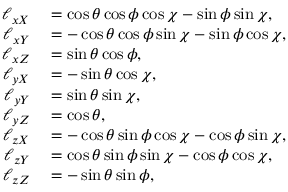Convert formula to latex. <formula><loc_0><loc_0><loc_500><loc_500>\begin{array} { r l } { \ell _ { x X } } & = \cos \theta \cos \phi \cos \chi - \sin \phi \sin \chi , } \\ { \ell _ { x Y } } & = - \cos \theta \cos \phi \sin \chi - \sin \phi \cos \chi , } \\ { \ell _ { x Z } } & = \sin \theta \cos \phi , } \\ { \ell _ { y X } } & = - \sin \theta \cos \chi , } \\ { \ell _ { y Y } } & = \sin \theta \sin \chi , } \\ { \ell _ { y Z } } & = \cos \theta , } \\ { \ell _ { z X } } & = - \cos \theta \sin \phi \cos \chi - \cos \phi \sin \chi , } \\ { \ell _ { z Y } } & = \cos \theta \sin \phi \sin \chi - \cos \phi \cos \chi , } \\ { \ell _ { z Z } } & = - \sin \theta \sin \phi , } \end{array}</formula> 